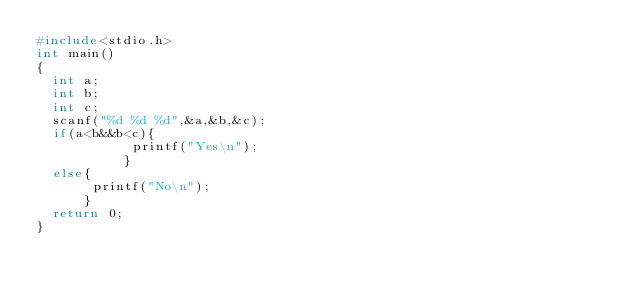<code> <loc_0><loc_0><loc_500><loc_500><_C_>#include<stdio.h>
int main()
{
  int a;
  int b;
  int c;
  scanf("%d %d %d",&a,&b,&c);
  if(a<b&&b<c){
            printf("Yes\n");
           }
  else{
       printf("No\n");
      }
  return 0;
}</code> 